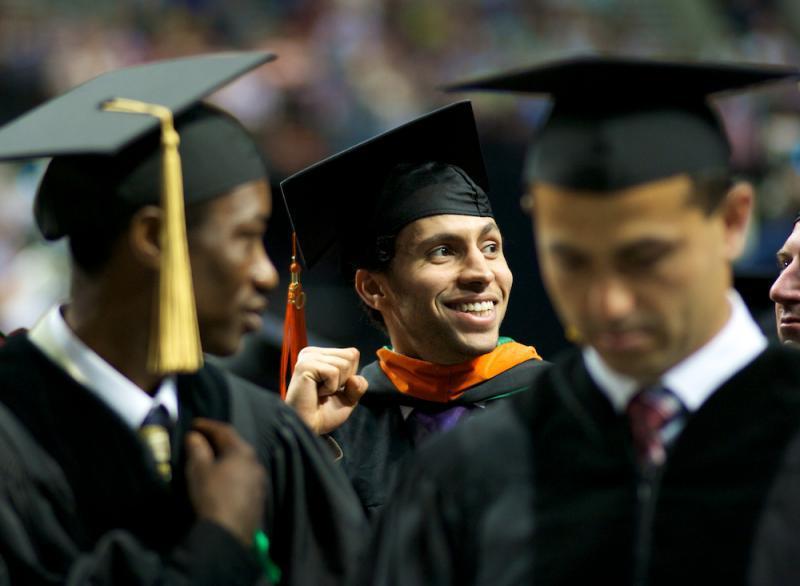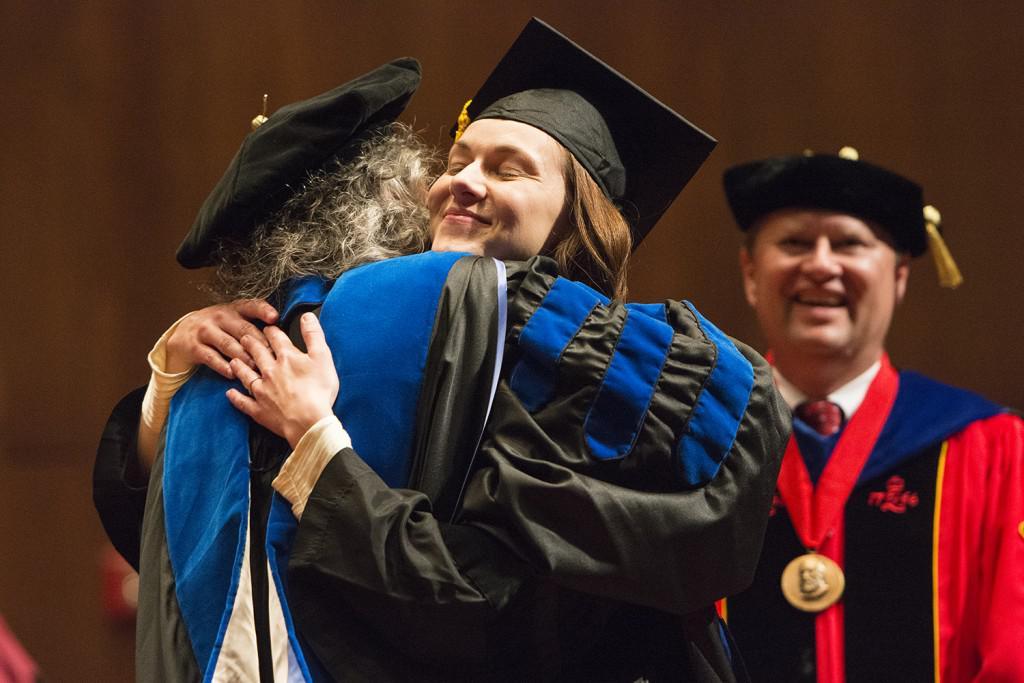The first image is the image on the left, the second image is the image on the right. Analyze the images presented: Is the assertion "There are 12 or more students wearing all-blue graduation gowns with white lapels." valid? Answer yes or no. No. The first image is the image on the left, the second image is the image on the right. Assess this claim about the two images: "There is a group of students walking in a line in the left image.". Correct or not? Answer yes or no. No. 